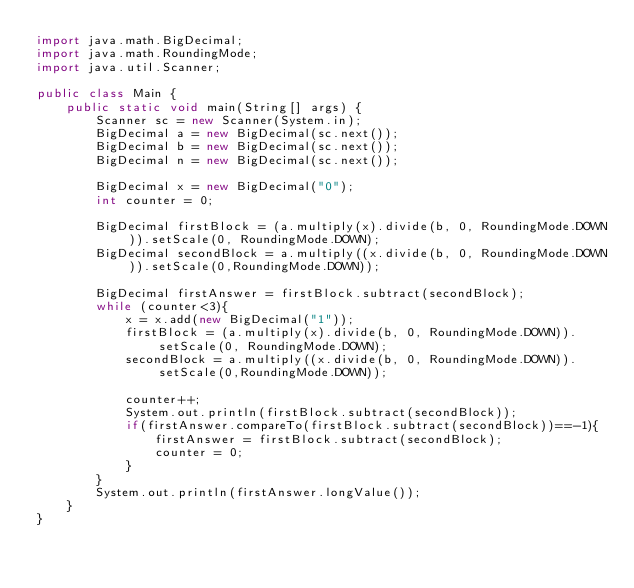<code> <loc_0><loc_0><loc_500><loc_500><_Java_>import java.math.BigDecimal;
import java.math.RoundingMode;
import java.util.Scanner;

public class Main {
    public static void main(String[] args) {
        Scanner sc = new Scanner(System.in);
        BigDecimal a = new BigDecimal(sc.next());
        BigDecimal b = new BigDecimal(sc.next());
        BigDecimal n = new BigDecimal(sc.next());

        BigDecimal x = new BigDecimal("0");
        int counter = 0;

        BigDecimal firstBlock = (a.multiply(x).divide(b, 0, RoundingMode.DOWN)).setScale(0, RoundingMode.DOWN);
        BigDecimal secondBlock = a.multiply((x.divide(b, 0, RoundingMode.DOWN)).setScale(0,RoundingMode.DOWN));

        BigDecimal firstAnswer = firstBlock.subtract(secondBlock);
        while (counter<3){
            x = x.add(new BigDecimal("1"));
            firstBlock = (a.multiply(x).divide(b, 0, RoundingMode.DOWN)).setScale(0, RoundingMode.DOWN);
            secondBlock = a.multiply((x.divide(b, 0, RoundingMode.DOWN)).setScale(0,RoundingMode.DOWN));

            counter++;
            System.out.println(firstBlock.subtract(secondBlock));
            if(firstAnswer.compareTo(firstBlock.subtract(secondBlock))==-1){
                firstAnswer = firstBlock.subtract(secondBlock);
                counter = 0;
            }
        }
        System.out.println(firstAnswer.longValue());
    }
}
</code> 